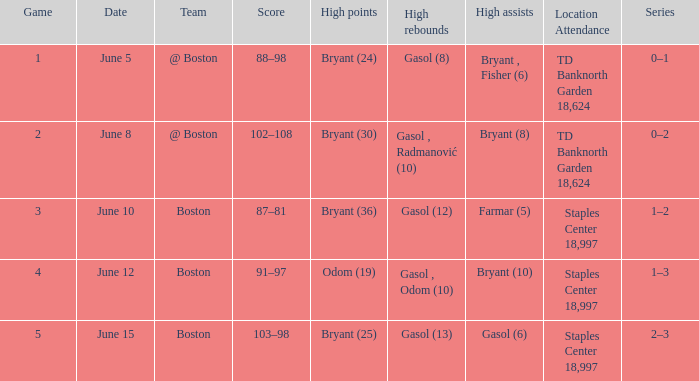Name the series on june 5 0–1. 